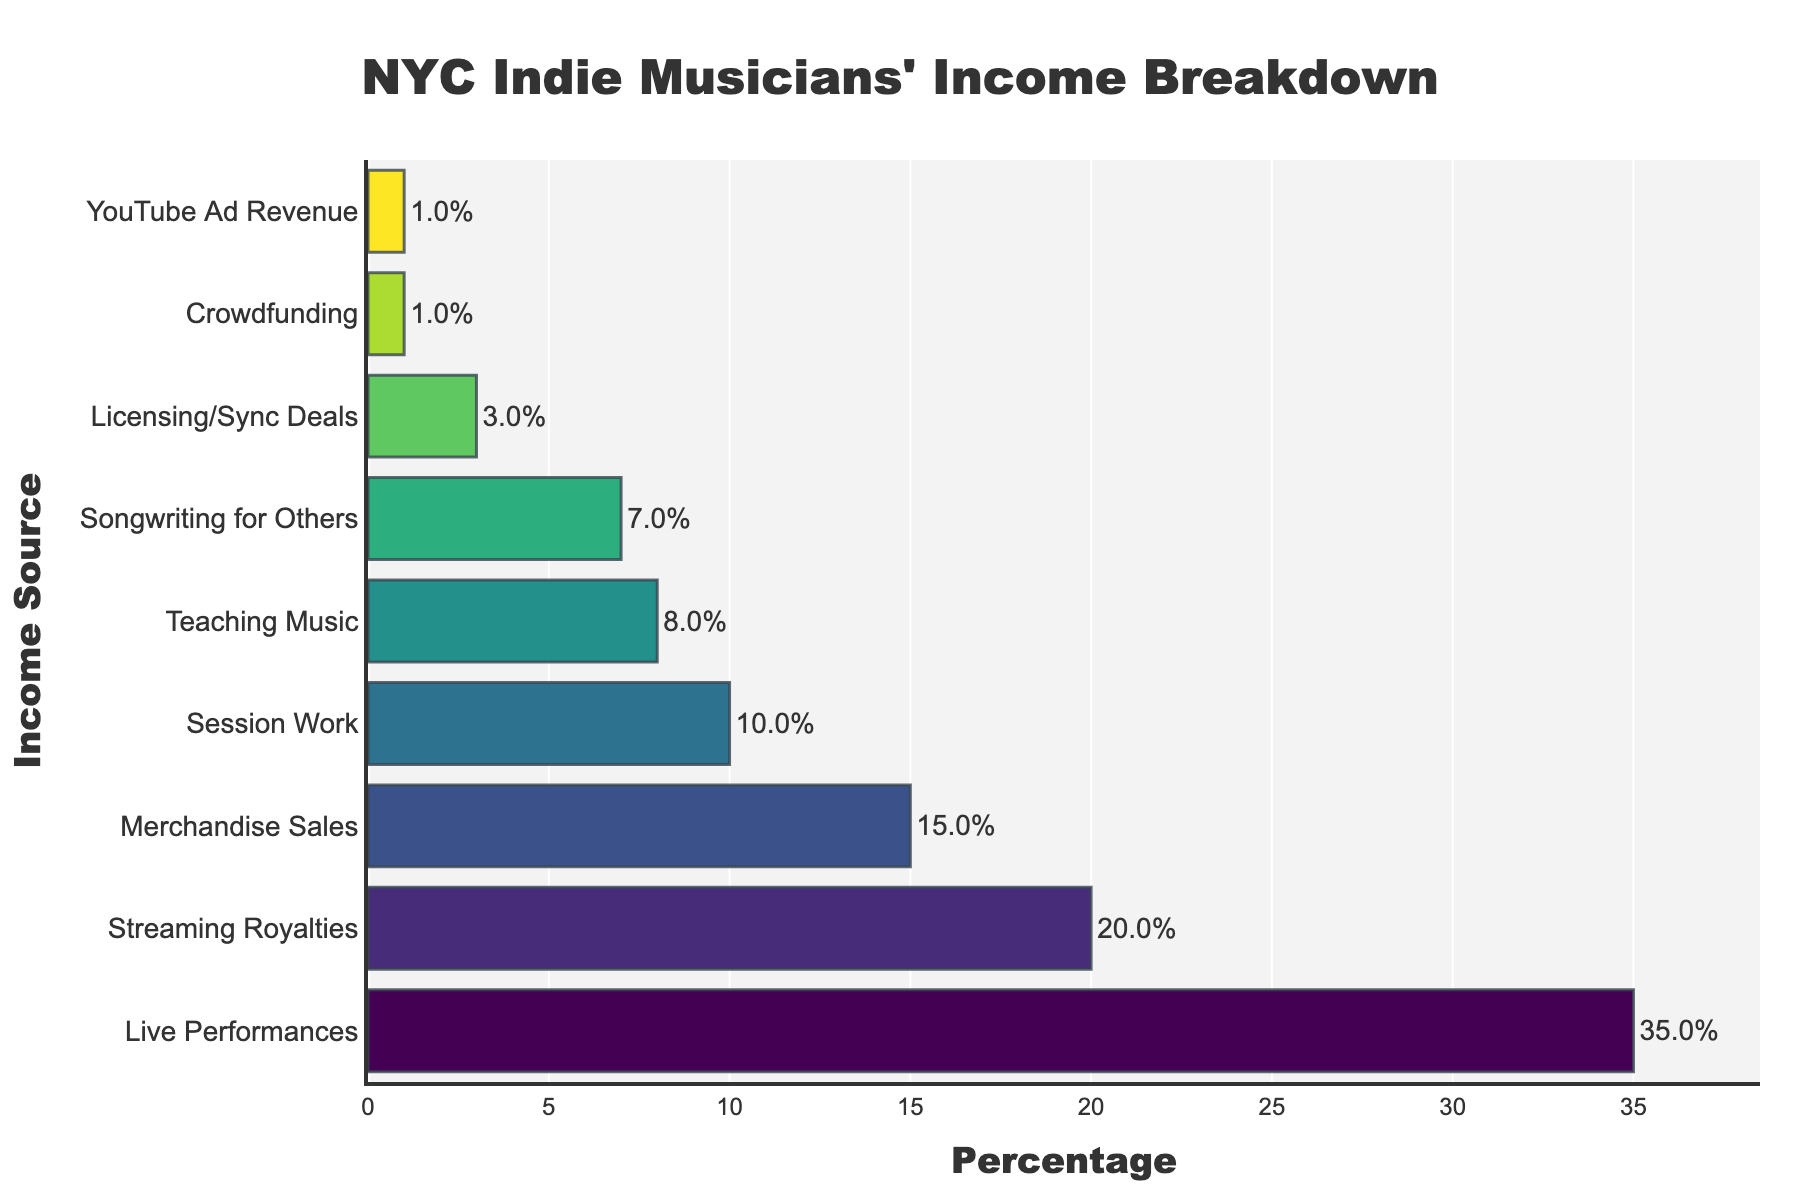What's the largest income source for independent musicians in NYC? The bar chart shows different income sources, and we can see that "Live Performances" has the longest bar, indicating that it has the highest percentage.
Answer: Live Performances Which income sources collectively contribute to more than 50% of the income for independent musicians in NYC? By adding the percentages of the top income sources until the sum exceeds 50%, we see that "Live Performances" (35%) and "Streaming Royalties" (20%) together contribute 35% + 20% = 55%.
Answer: Live Performances and Streaming Royalties How much more percentage do Live Performances contribute compared to Teaching Music? The percentage for Live Performances is 35%, and for Teaching Music, it is 8%. The difference is 35% - 8% = 27%.
Answer: 27% What is the total percentage contributed by the least three income sources? The least three income sources are "Licensing/Sync Deals" (3%), "Crowdfunding" (1%), and "YouTube Ad Revenue" (1%). The total is 3% + 1% + 1% = 5%.
Answer: 5% Which income source has exactly half the percentage of Streaming Royalties? Streaming Royalties have a percentage of 20%. Half of 20% is 10%, which matches "Session Work" in the chart.
Answer: Session Work What is the median income source percentage, and which source does it correspond to? To find the median, we list the percentages in order: 1, 1, 3, 7, 8, 10, 15, 20, 35. The median is the middle value, which is the 5th value in the list: 8%. This corresponds to "Teaching Music".
Answer: Teaching Music (8%) Are Merchandise Sales or Session Work more significant contributors to the income? By comparing the bar lengths and percentages, Merchandise Sales contribute 15%, whereas Session Work contributes 10%.
Answer: Merchandise Sales Which income source is closer in percentage to Songwriting for Others: Teaching Music or Merchandise Sales? Songwriting for Others has 7%. Teaching Music has 8% (a difference of 1%), and Merchandise Sales have 15% (a difference of 8%). Therefore, Teaching Music is closer.
Answer: Teaching Music Which income sources collectively make up for less than 10% of the income? We check the percentages of smaller contributions and find that "Licensing/Sync Deals" (3%), "Crowdfunding" (1%), and "YouTube Ad Revenue" (1%) make up 3% + 1% + 1% = 5%, which is less than 10%.
Answer: Licensing/Sync Deals, Crowdfunding, and YouTube Ad Revenue What is the average percentage of the four highest income sources? The four highest percentages are 35%, 20%, 15%, and 10%. Their total is 35% + 20% + 15% + 10% = 80%. Dividing by 4 gives an average of 80% / 4 = 20%.
Answer: 20% 